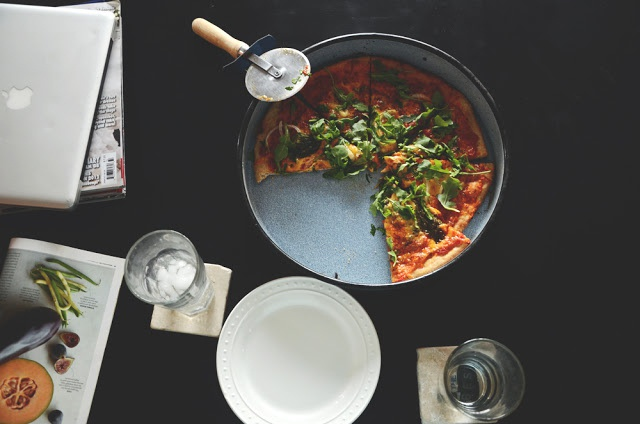Describe the objects in this image and their specific colors. I can see dining table in black, lightgray, darkgray, gray, and maroon tones, pizza in black, maroon, darkgreen, and brown tones, bowl in black, lightgray, and darkgray tones, laptop in black, lightgray, and darkgray tones, and book in black, darkgray, lightgray, and gray tones in this image. 